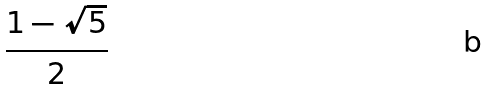<formula> <loc_0><loc_0><loc_500><loc_500>\frac { 1 - \sqrt { 5 } } { 2 }</formula> 